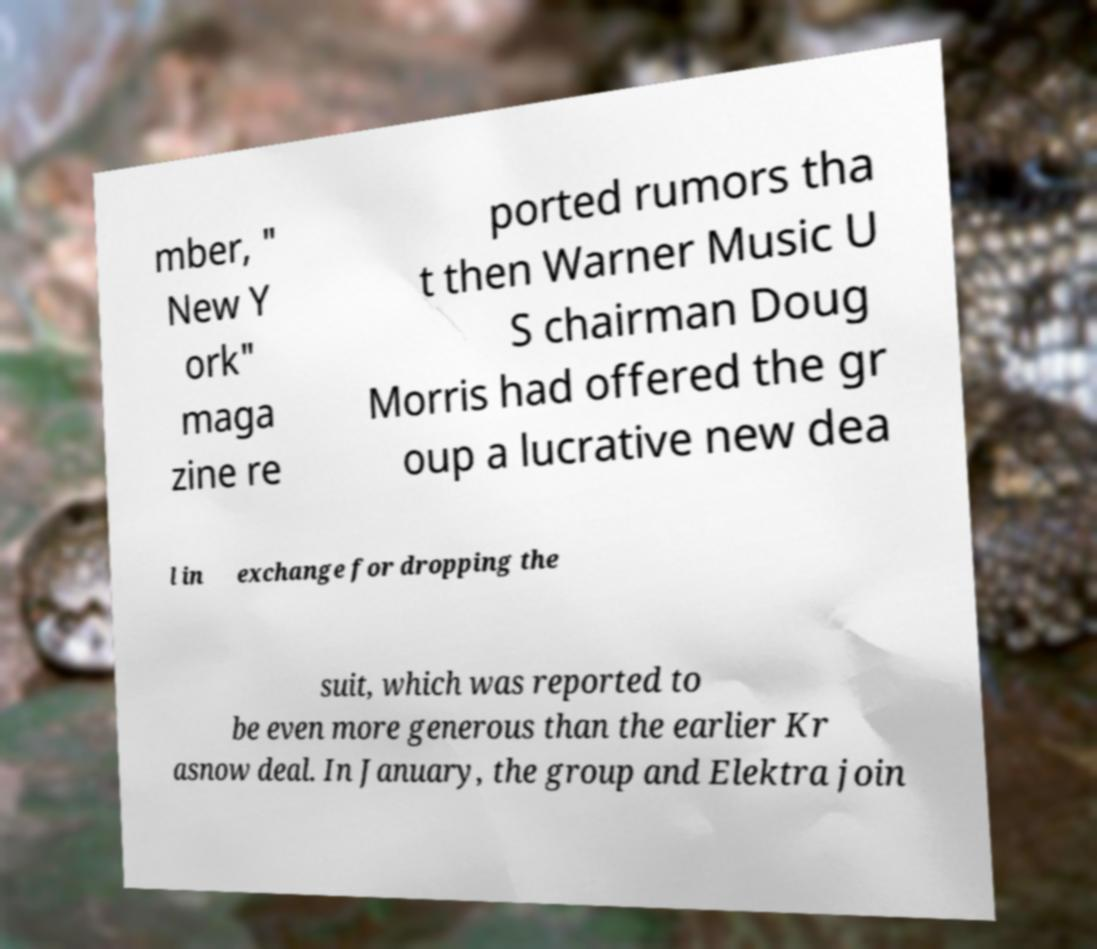What messages or text are displayed in this image? I need them in a readable, typed format. mber, " New Y ork" maga zine re ported rumors tha t then Warner Music U S chairman Doug Morris had offered the gr oup a lucrative new dea l in exchange for dropping the suit, which was reported to be even more generous than the earlier Kr asnow deal. In January, the group and Elektra join 